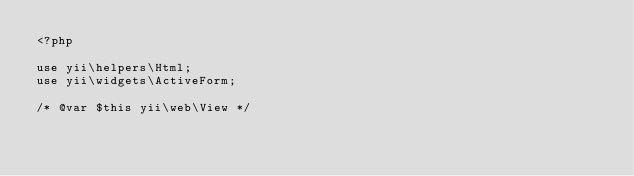<code> <loc_0><loc_0><loc_500><loc_500><_PHP_><?php

use yii\helpers\Html;
use yii\widgets\ActiveForm;

/* @var $this yii\web\View */</code> 